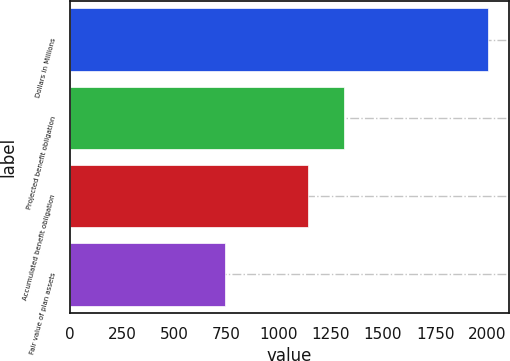Convert chart. <chart><loc_0><loc_0><loc_500><loc_500><bar_chart><fcel>Dollars in Millions<fcel>Projected benefit obligation<fcel>Accumulated benefit obligation<fcel>Fair value of plan assets<nl><fcel>2004<fcel>1313<fcel>1139<fcel>742<nl></chart> 